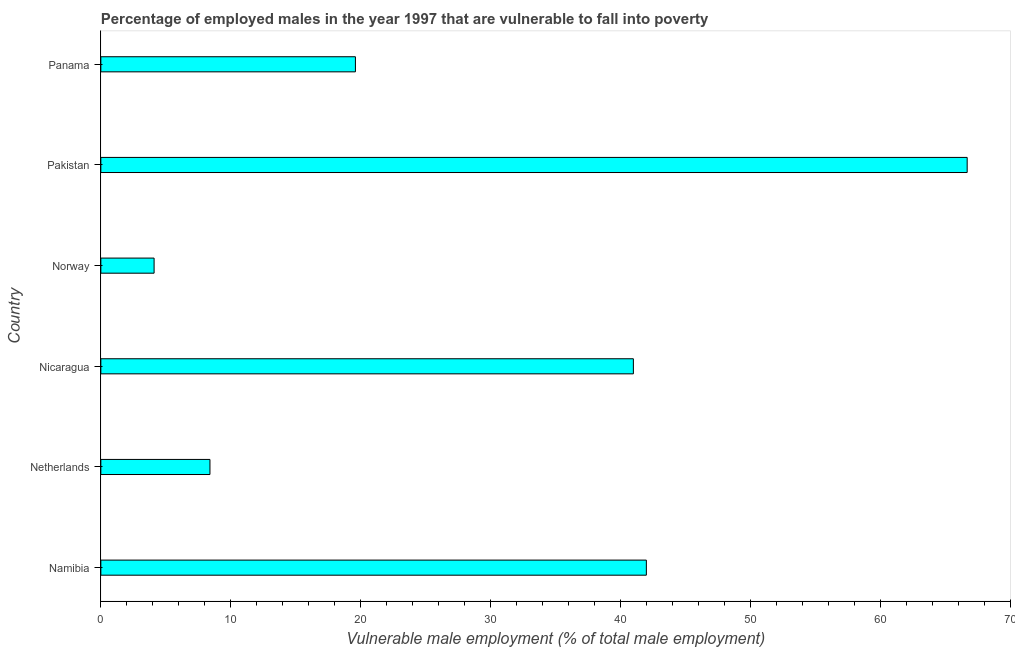What is the title of the graph?
Offer a very short reply. Percentage of employed males in the year 1997 that are vulnerable to fall into poverty. What is the label or title of the X-axis?
Your answer should be very brief. Vulnerable male employment (% of total male employment). What is the percentage of employed males who are vulnerable to fall into poverty in Netherlands?
Make the answer very short. 8.4. Across all countries, what is the maximum percentage of employed males who are vulnerable to fall into poverty?
Offer a terse response. 66.7. Across all countries, what is the minimum percentage of employed males who are vulnerable to fall into poverty?
Keep it short and to the point. 4.1. In which country was the percentage of employed males who are vulnerable to fall into poverty maximum?
Make the answer very short. Pakistan. What is the sum of the percentage of employed males who are vulnerable to fall into poverty?
Ensure brevity in your answer.  181.8. What is the difference between the percentage of employed males who are vulnerable to fall into poverty in Namibia and Norway?
Offer a terse response. 37.9. What is the average percentage of employed males who are vulnerable to fall into poverty per country?
Provide a succinct answer. 30.3. What is the median percentage of employed males who are vulnerable to fall into poverty?
Ensure brevity in your answer.  30.3. In how many countries, is the percentage of employed males who are vulnerable to fall into poverty greater than 34 %?
Your answer should be compact. 3. What is the ratio of the percentage of employed males who are vulnerable to fall into poverty in Namibia to that in Norway?
Offer a terse response. 10.24. Is the difference between the percentage of employed males who are vulnerable to fall into poverty in Namibia and Norway greater than the difference between any two countries?
Provide a succinct answer. No. What is the difference between the highest and the second highest percentage of employed males who are vulnerable to fall into poverty?
Give a very brief answer. 24.7. Is the sum of the percentage of employed males who are vulnerable to fall into poverty in Norway and Pakistan greater than the maximum percentage of employed males who are vulnerable to fall into poverty across all countries?
Provide a short and direct response. Yes. What is the difference between the highest and the lowest percentage of employed males who are vulnerable to fall into poverty?
Keep it short and to the point. 62.6. How many bars are there?
Your answer should be very brief. 6. How many countries are there in the graph?
Provide a short and direct response. 6. What is the difference between two consecutive major ticks on the X-axis?
Give a very brief answer. 10. Are the values on the major ticks of X-axis written in scientific E-notation?
Offer a terse response. No. What is the Vulnerable male employment (% of total male employment) of Netherlands?
Provide a short and direct response. 8.4. What is the Vulnerable male employment (% of total male employment) in Norway?
Provide a succinct answer. 4.1. What is the Vulnerable male employment (% of total male employment) in Pakistan?
Offer a very short reply. 66.7. What is the Vulnerable male employment (% of total male employment) of Panama?
Your answer should be compact. 19.6. What is the difference between the Vulnerable male employment (% of total male employment) in Namibia and Netherlands?
Provide a succinct answer. 33.6. What is the difference between the Vulnerable male employment (% of total male employment) in Namibia and Norway?
Your response must be concise. 37.9. What is the difference between the Vulnerable male employment (% of total male employment) in Namibia and Pakistan?
Give a very brief answer. -24.7. What is the difference between the Vulnerable male employment (% of total male employment) in Namibia and Panama?
Your answer should be very brief. 22.4. What is the difference between the Vulnerable male employment (% of total male employment) in Netherlands and Nicaragua?
Provide a succinct answer. -32.6. What is the difference between the Vulnerable male employment (% of total male employment) in Netherlands and Pakistan?
Keep it short and to the point. -58.3. What is the difference between the Vulnerable male employment (% of total male employment) in Nicaragua and Norway?
Your answer should be compact. 36.9. What is the difference between the Vulnerable male employment (% of total male employment) in Nicaragua and Pakistan?
Offer a terse response. -25.7. What is the difference between the Vulnerable male employment (% of total male employment) in Nicaragua and Panama?
Your answer should be very brief. 21.4. What is the difference between the Vulnerable male employment (% of total male employment) in Norway and Pakistan?
Your answer should be compact. -62.6. What is the difference between the Vulnerable male employment (% of total male employment) in Norway and Panama?
Give a very brief answer. -15.5. What is the difference between the Vulnerable male employment (% of total male employment) in Pakistan and Panama?
Your answer should be compact. 47.1. What is the ratio of the Vulnerable male employment (% of total male employment) in Namibia to that in Netherlands?
Offer a very short reply. 5. What is the ratio of the Vulnerable male employment (% of total male employment) in Namibia to that in Nicaragua?
Ensure brevity in your answer.  1.02. What is the ratio of the Vulnerable male employment (% of total male employment) in Namibia to that in Norway?
Provide a succinct answer. 10.24. What is the ratio of the Vulnerable male employment (% of total male employment) in Namibia to that in Pakistan?
Make the answer very short. 0.63. What is the ratio of the Vulnerable male employment (% of total male employment) in Namibia to that in Panama?
Offer a terse response. 2.14. What is the ratio of the Vulnerable male employment (% of total male employment) in Netherlands to that in Nicaragua?
Keep it short and to the point. 0.2. What is the ratio of the Vulnerable male employment (% of total male employment) in Netherlands to that in Norway?
Keep it short and to the point. 2.05. What is the ratio of the Vulnerable male employment (% of total male employment) in Netherlands to that in Pakistan?
Offer a terse response. 0.13. What is the ratio of the Vulnerable male employment (% of total male employment) in Netherlands to that in Panama?
Provide a succinct answer. 0.43. What is the ratio of the Vulnerable male employment (% of total male employment) in Nicaragua to that in Pakistan?
Your answer should be compact. 0.61. What is the ratio of the Vulnerable male employment (% of total male employment) in Nicaragua to that in Panama?
Give a very brief answer. 2.09. What is the ratio of the Vulnerable male employment (% of total male employment) in Norway to that in Pakistan?
Keep it short and to the point. 0.06. What is the ratio of the Vulnerable male employment (% of total male employment) in Norway to that in Panama?
Your answer should be very brief. 0.21. What is the ratio of the Vulnerable male employment (% of total male employment) in Pakistan to that in Panama?
Give a very brief answer. 3.4. 